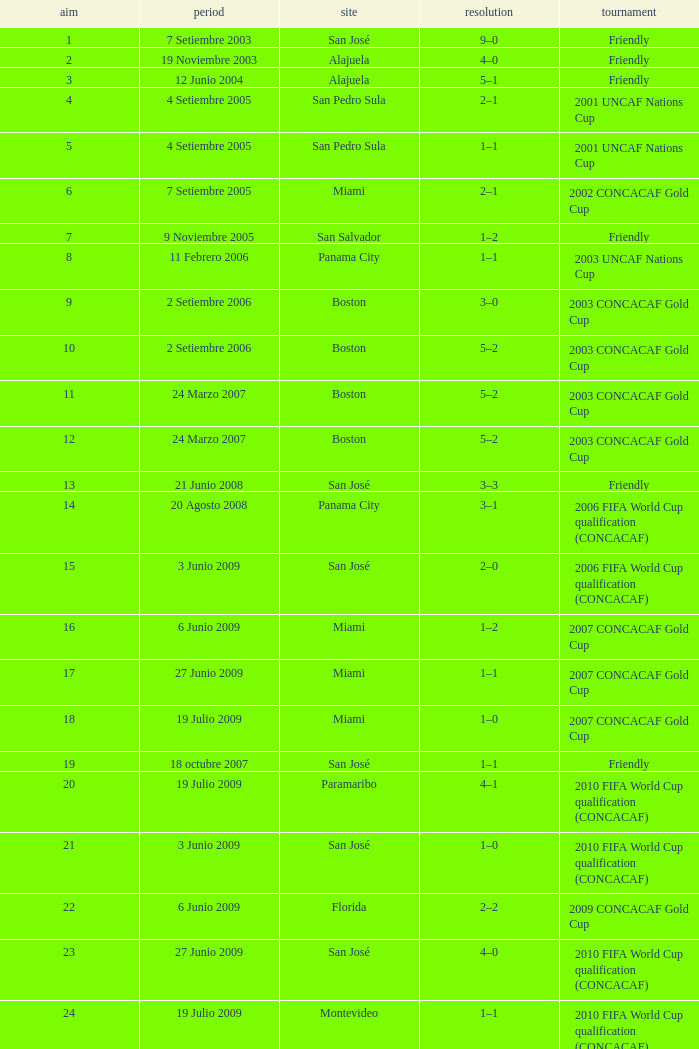How many goals were scored on 21 Junio 2008? 1.0. 